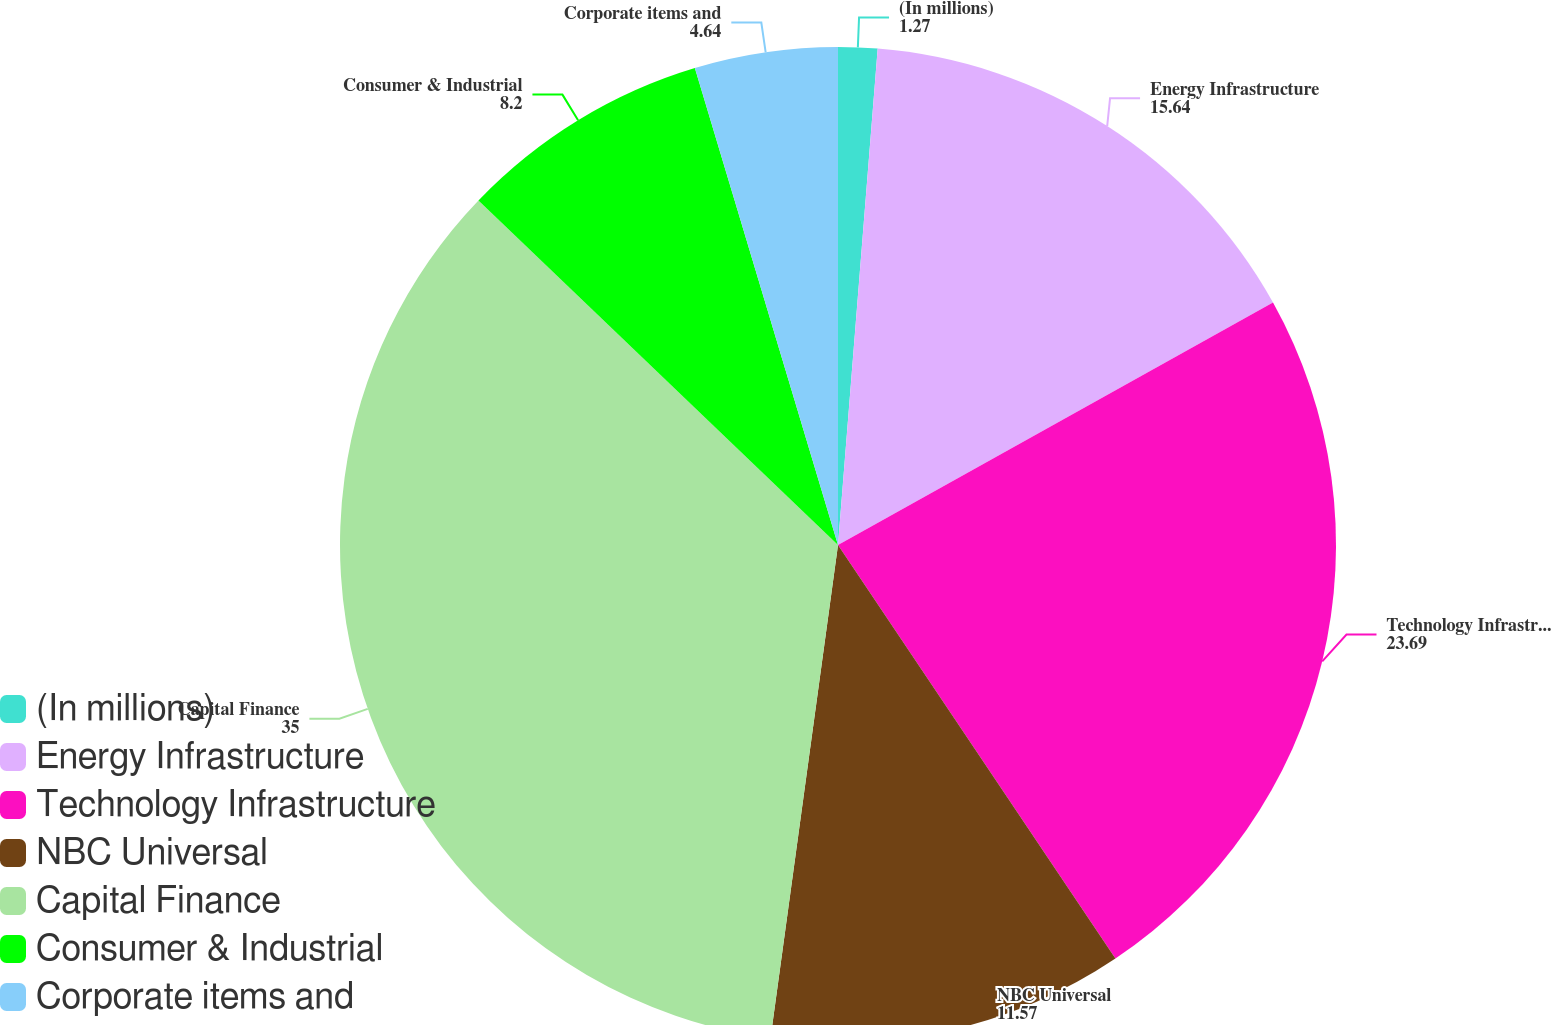Convert chart. <chart><loc_0><loc_0><loc_500><loc_500><pie_chart><fcel>(In millions)<fcel>Energy Infrastructure<fcel>Technology Infrastructure<fcel>NBC Universal<fcel>Capital Finance<fcel>Consumer & Industrial<fcel>Corporate items and<nl><fcel>1.27%<fcel>15.64%<fcel>23.69%<fcel>11.57%<fcel>35.0%<fcel>8.2%<fcel>4.64%<nl></chart> 